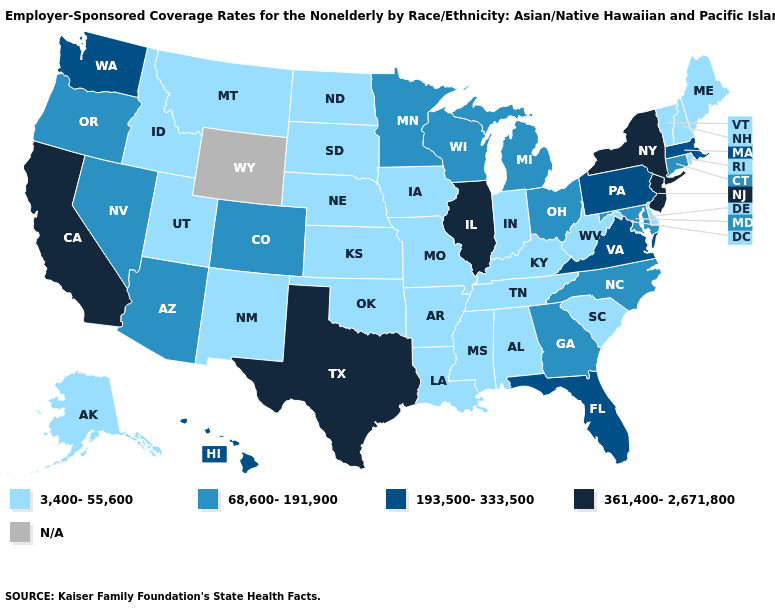Which states have the highest value in the USA?
Be succinct. California, Illinois, New Jersey, New York, Texas. What is the value of Tennessee?
Quick response, please. 3,400-55,600. What is the highest value in the USA?
Short answer required. 361,400-2,671,800. Among the states that border Nebraska , does Missouri have the highest value?
Quick response, please. No. What is the highest value in the MidWest ?
Concise answer only. 361,400-2,671,800. Does the first symbol in the legend represent the smallest category?
Write a very short answer. Yes. Which states hav the highest value in the South?
Answer briefly. Texas. What is the value of Washington?
Short answer required. 193,500-333,500. Name the states that have a value in the range 68,600-191,900?
Give a very brief answer. Arizona, Colorado, Connecticut, Georgia, Maryland, Michigan, Minnesota, Nevada, North Carolina, Ohio, Oregon, Wisconsin. Does the first symbol in the legend represent the smallest category?
Keep it brief. Yes. What is the value of Texas?
Short answer required. 361,400-2,671,800. What is the value of Vermont?
Write a very short answer. 3,400-55,600. Among the states that border Georgia , which have the lowest value?
Answer briefly. Alabama, South Carolina, Tennessee. Does California have the highest value in the West?
Short answer required. Yes. 